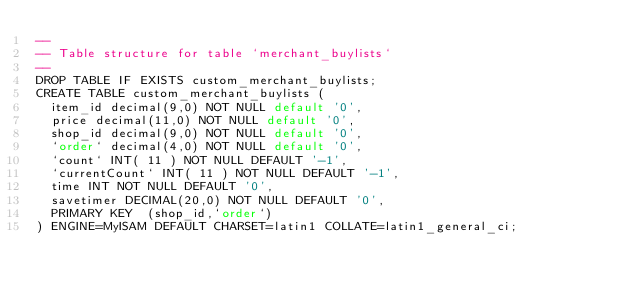Convert code to text. <code><loc_0><loc_0><loc_500><loc_500><_SQL_>--
-- Table structure for table `merchant_buylists`
--
DROP TABLE IF EXISTS custom_merchant_buylists;
CREATE TABLE custom_merchant_buylists (
  item_id decimal(9,0) NOT NULL default '0',
  price decimal(11,0) NOT NULL default '0',
  shop_id decimal(9,0) NOT NULL default '0',
  `order` decimal(4,0) NOT NULL default '0',
  `count` INT( 11 ) NOT NULL DEFAULT '-1',
  `currentCount` INT( 11 ) NOT NULL DEFAULT '-1',
  time INT NOT NULL DEFAULT '0',
  savetimer DECIMAL(20,0) NOT NULL DEFAULT '0',
  PRIMARY KEY  (shop_id,`order`)
) ENGINE=MyISAM DEFAULT CHARSET=latin1 COLLATE=latin1_general_ci;</code> 